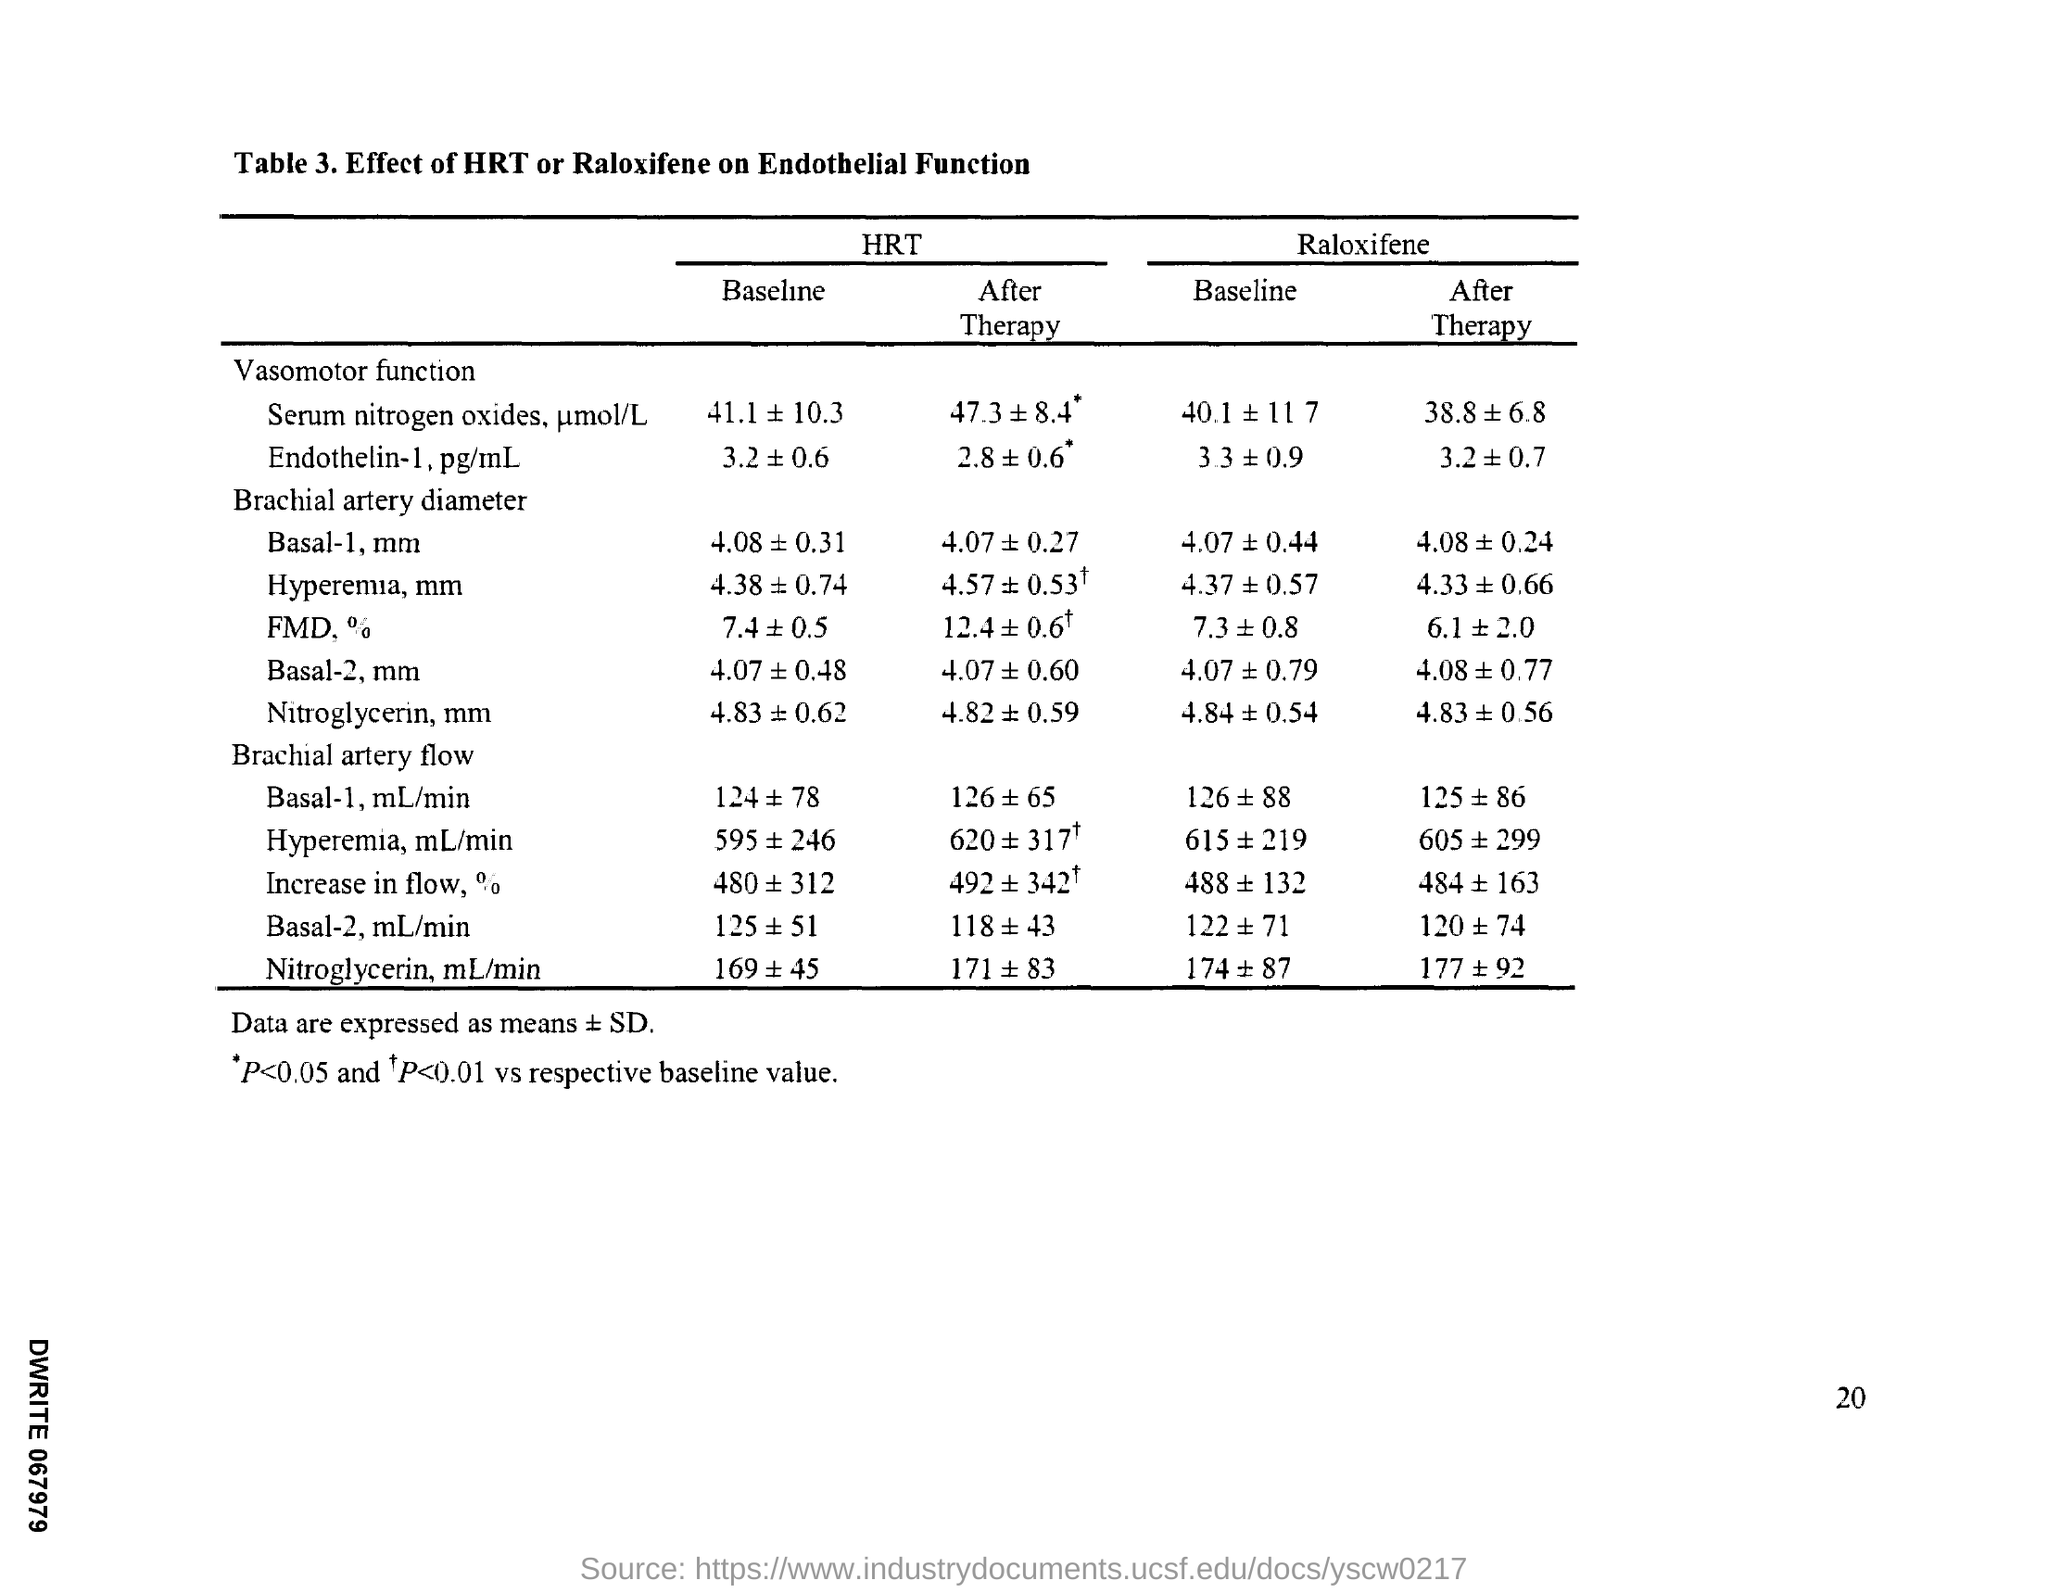What is the Page Number?
Your answer should be compact. 20. 